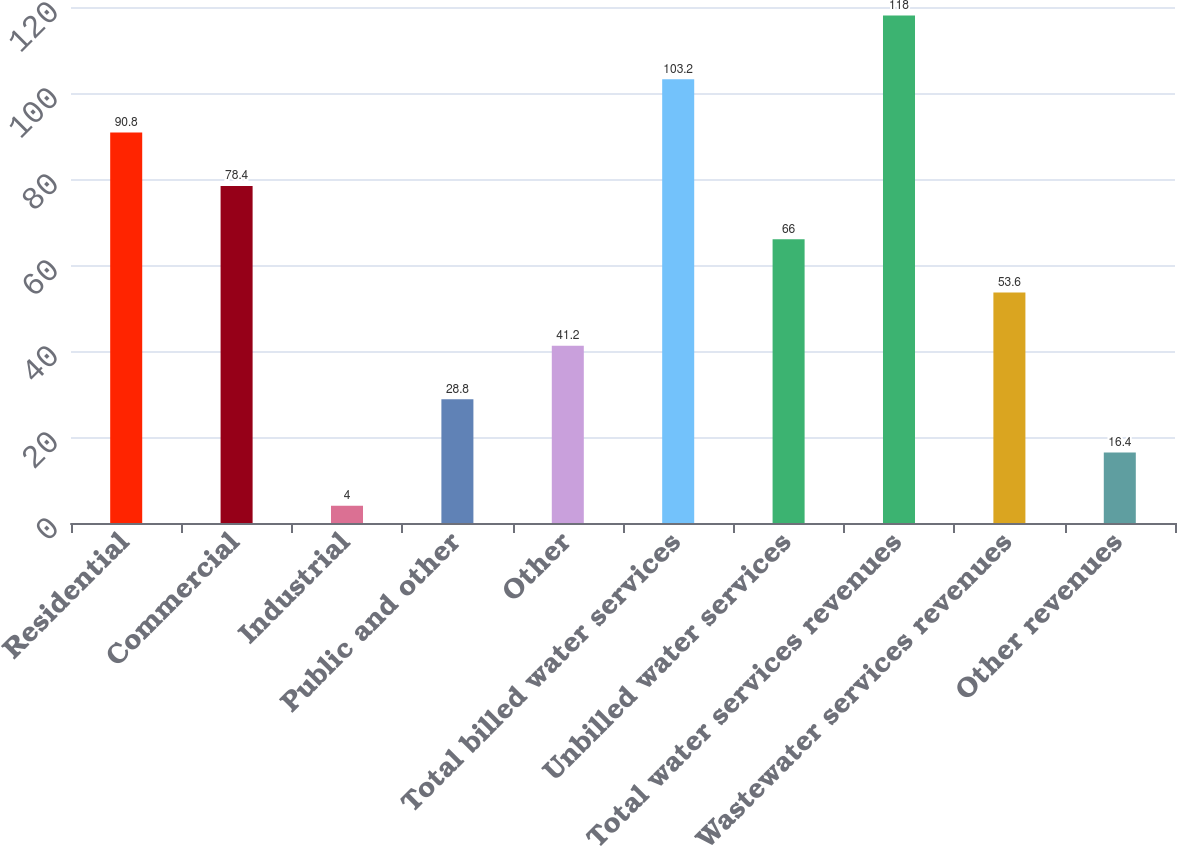<chart> <loc_0><loc_0><loc_500><loc_500><bar_chart><fcel>Residential<fcel>Commercial<fcel>Industrial<fcel>Public and other<fcel>Other<fcel>Total billed water services<fcel>Unbilled water services<fcel>Total water services revenues<fcel>Wastewater services revenues<fcel>Other revenues<nl><fcel>90.8<fcel>78.4<fcel>4<fcel>28.8<fcel>41.2<fcel>103.2<fcel>66<fcel>118<fcel>53.6<fcel>16.4<nl></chart> 